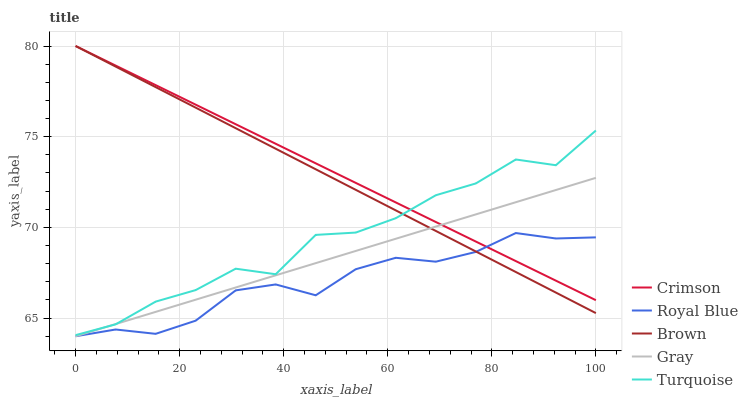Does Royal Blue have the minimum area under the curve?
Answer yes or no. Yes. Does Crimson have the maximum area under the curve?
Answer yes or no. Yes. Does Gray have the minimum area under the curve?
Answer yes or no. No. Does Gray have the maximum area under the curve?
Answer yes or no. No. Is Crimson the smoothest?
Answer yes or no. Yes. Is Turquoise the roughest?
Answer yes or no. Yes. Is Royal Blue the smoothest?
Answer yes or no. No. Is Royal Blue the roughest?
Answer yes or no. No. Does Royal Blue have the lowest value?
Answer yes or no. Yes. Does Turquoise have the lowest value?
Answer yes or no. No. Does Brown have the highest value?
Answer yes or no. Yes. Does Gray have the highest value?
Answer yes or no. No. Is Royal Blue less than Turquoise?
Answer yes or no. Yes. Is Turquoise greater than Royal Blue?
Answer yes or no. Yes. Does Gray intersect Royal Blue?
Answer yes or no. Yes. Is Gray less than Royal Blue?
Answer yes or no. No. Is Gray greater than Royal Blue?
Answer yes or no. No. Does Royal Blue intersect Turquoise?
Answer yes or no. No. 